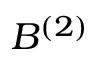Convert formula to latex. <formula><loc_0><loc_0><loc_500><loc_500>B ^ { ( 2 ) }</formula> 